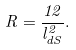Convert formula to latex. <formula><loc_0><loc_0><loc_500><loc_500>R = \frac { 1 2 } { l _ { d S } ^ { 2 } } .</formula> 